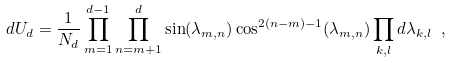Convert formula to latex. <formula><loc_0><loc_0><loc_500><loc_500>d U _ { d } = \frac { 1 } { N _ { d } } \prod _ { m = 1 } ^ { d - 1 } \prod _ { n = m + 1 } ^ { d } \sin ( \lambda _ { m , n } ) \cos ^ { 2 ( n - m ) - 1 } ( \lambda _ { m , n } ) \prod _ { k , l } d \lambda _ { k , l } \ ,</formula> 